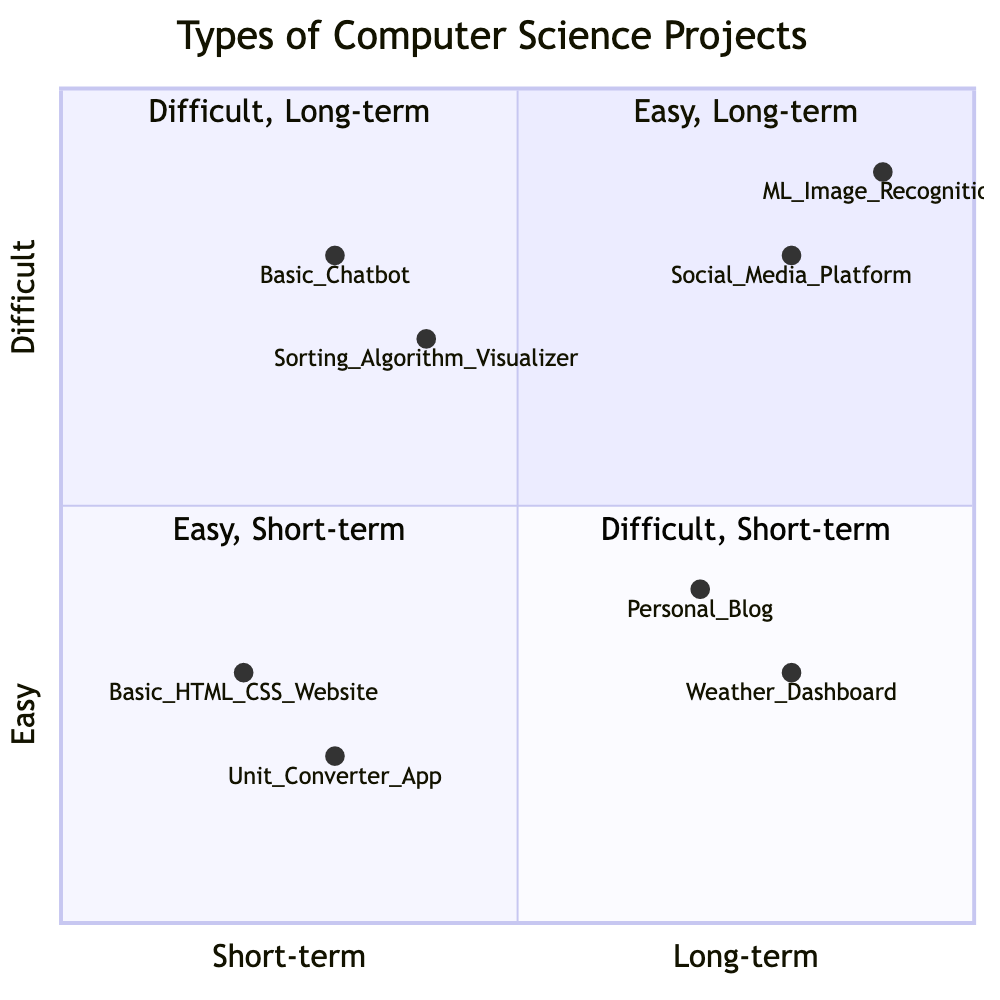What is the number of projects in the Difficult, Long-term quadrant? In the Difficult, Long-term quadrant, there are two projects listed: "Machine Learning Model for Image Recognition" and "Social Media Platform." Thus, by counting them, the total number of projects is two.
Answer: 2 Which project is located at the highest difficulty level? The highest difficulty level is at the top of the chart (Difficult), specifically in the quadrant representing Long-term assignments. The project "Machine Learning Model for Image Recognition" is located at the highest point on the Y-axis, indicating it is the most difficult.
Answer: Machine Learning Model for Image Recognition How many projects are categorized as Easy, Short-term? The Easy, Short-term quadrant has two projects listed: "Basic HTML/CSS Website" and "Unit Converter App." So, by counting these, we find that there are two projects in this category.
Answer: 2 Which project has the longest duration among the Difficult projects? In the Difficult category, we look at the Long-term quadrant where "Machine Learning Model for Image Recognition" and "Social Media Platform" are located. Hence, since both are long-term, we can confirm that they are the longest duration projects in this category.
Answer: Machine Learning Model for Image Recognition Is there any project that is both Easy and Long-term? In the Easy, Long-term quadrant, there are two projects: "Personal Blog" and "Weather Dashboard." Both fit the criteria of being Easy and having a Long-term duration. Hence, there are two projects that satisfy this condition.
Answer: Personal Blog, Weather Dashboard Which project is the easiest among the Difficult, Short-term assignments? Among the Difficult, Short-term quadrant, we have "Sorting Algorithm Visualizer" and "Basic Chatbot." To find the easiest, we assess their positions. "Basic Chatbot" is positioned lower than "Sorting Algorithm Visualizer" on the Y-axis. Therefore, it is the easier project.
Answer: Basic Chatbot What project is the most difficult short-term assignment? The highest position in the Difficult, Short-term quadrant belongs to "Basic Chatbot," which is on the right side compared to "Sorting Algorithm Visualizer." This indicates that it is considered the most difficult project while still being a Short-term assignment.
Answer: Basic Chatbot Which quadrant contains projects that are not difficult at all? The quadrant that contains projects that are categorized as Easy, specifically the Easy, Short-term quadrant, does not include any projects that are difficult. Therefore, it exclusively contains simpler projects.
Answer: Easy, Short-term 